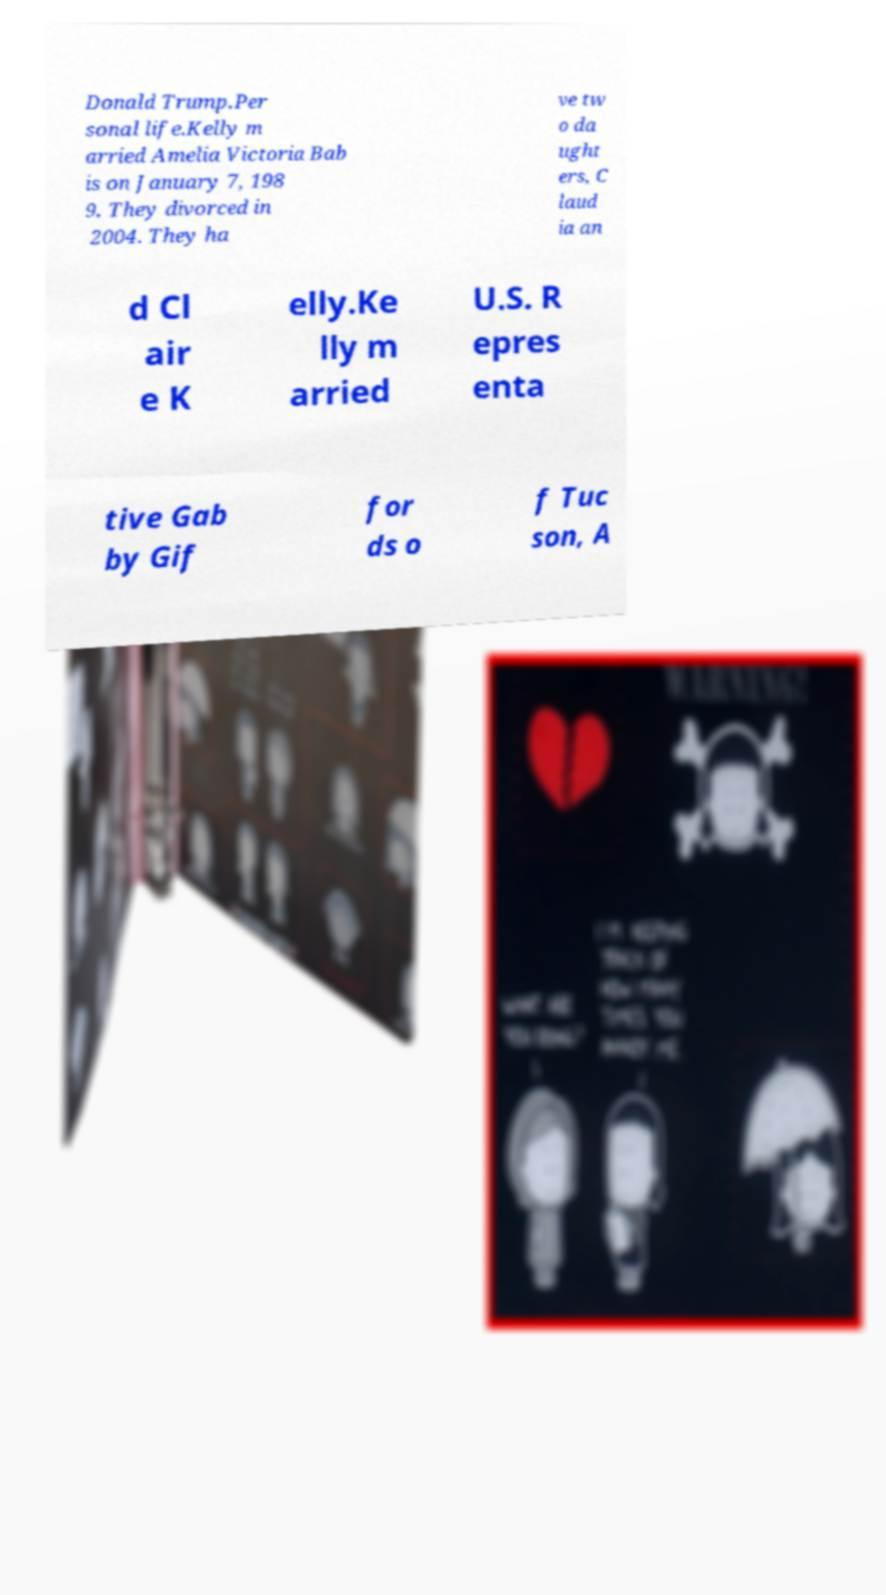Can you read and provide the text displayed in the image?This photo seems to have some interesting text. Can you extract and type it out for me? Donald Trump.Per sonal life.Kelly m arried Amelia Victoria Bab is on January 7, 198 9. They divorced in 2004. They ha ve tw o da ught ers, C laud ia an d Cl air e K elly.Ke lly m arried U.S. R epres enta tive Gab by Gif for ds o f Tuc son, A 